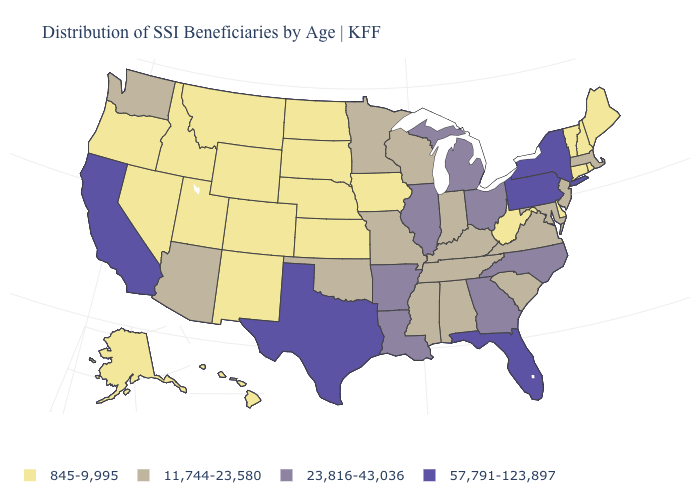What is the value of Maryland?
Give a very brief answer. 11,744-23,580. What is the value of New Hampshire?
Be succinct. 845-9,995. What is the lowest value in the West?
Write a very short answer. 845-9,995. What is the value of Maine?
Be succinct. 845-9,995. What is the value of Wisconsin?
Answer briefly. 11,744-23,580. What is the lowest value in the USA?
Concise answer only. 845-9,995. Name the states that have a value in the range 845-9,995?
Quick response, please. Alaska, Colorado, Connecticut, Delaware, Hawaii, Idaho, Iowa, Kansas, Maine, Montana, Nebraska, Nevada, New Hampshire, New Mexico, North Dakota, Oregon, Rhode Island, South Dakota, Utah, Vermont, West Virginia, Wyoming. Does Oklahoma have a higher value than California?
Answer briefly. No. What is the value of Minnesota?
Give a very brief answer. 11,744-23,580. Does Delaware have the lowest value in the South?
Write a very short answer. Yes. Name the states that have a value in the range 845-9,995?
Quick response, please. Alaska, Colorado, Connecticut, Delaware, Hawaii, Idaho, Iowa, Kansas, Maine, Montana, Nebraska, Nevada, New Hampshire, New Mexico, North Dakota, Oregon, Rhode Island, South Dakota, Utah, Vermont, West Virginia, Wyoming. What is the lowest value in the USA?
Keep it brief. 845-9,995. What is the value of Pennsylvania?
Short answer required. 57,791-123,897. Does Maine have the highest value in the Northeast?
Be succinct. No. Does the map have missing data?
Quick response, please. No. 